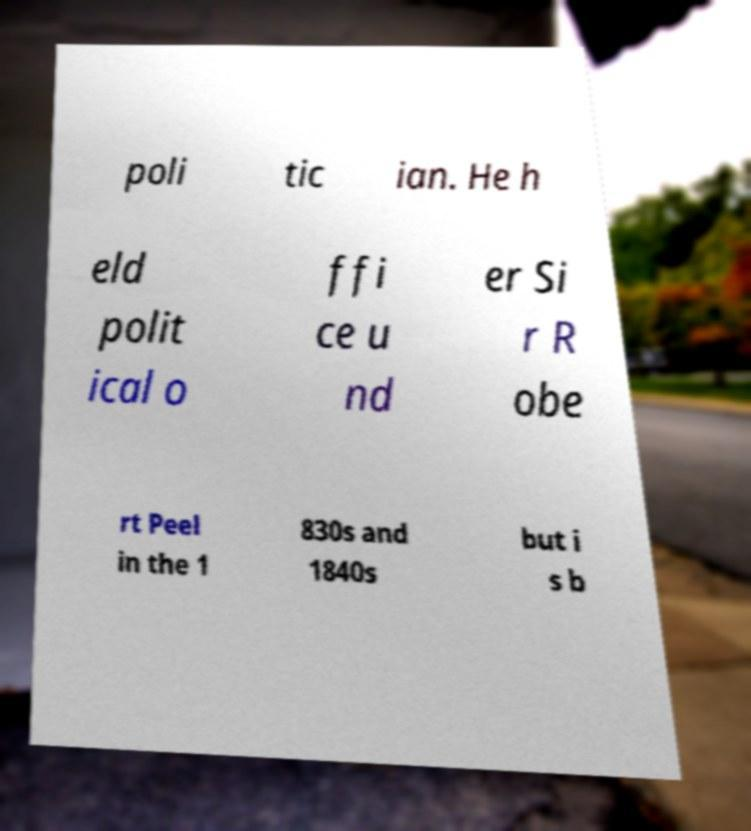Can you accurately transcribe the text from the provided image for me? poli tic ian. He h eld polit ical o ffi ce u nd er Si r R obe rt Peel in the 1 830s and 1840s but i s b 